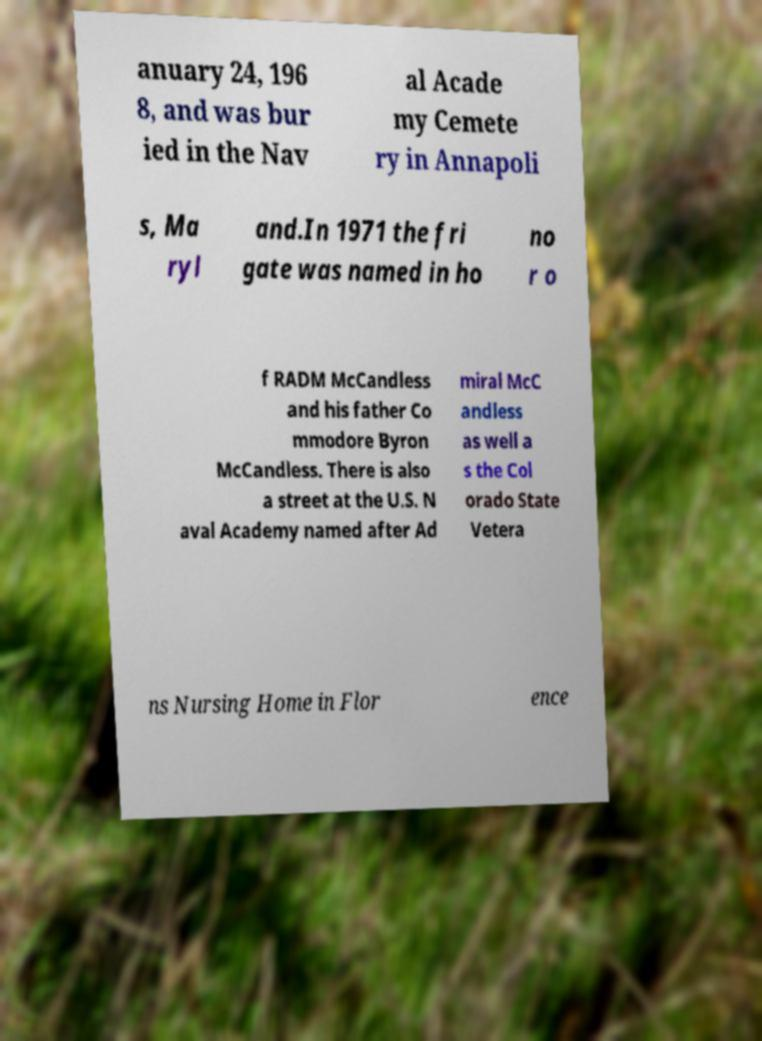Please read and relay the text visible in this image. What does it say? anuary 24, 196 8, and was bur ied in the Nav al Acade my Cemete ry in Annapoli s, Ma ryl and.In 1971 the fri gate was named in ho no r o f RADM McCandless and his father Co mmodore Byron McCandless. There is also a street at the U.S. N aval Academy named after Ad miral McC andless as well a s the Col orado State Vetera ns Nursing Home in Flor ence 